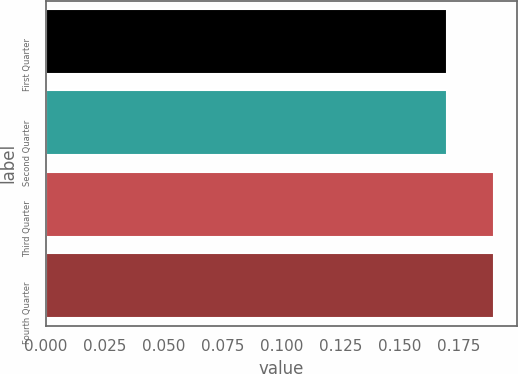Convert chart. <chart><loc_0><loc_0><loc_500><loc_500><bar_chart><fcel>First Quarter<fcel>Second Quarter<fcel>Third Quarter<fcel>Fourth Quarter<nl><fcel>0.17<fcel>0.17<fcel>0.19<fcel>0.19<nl></chart> 